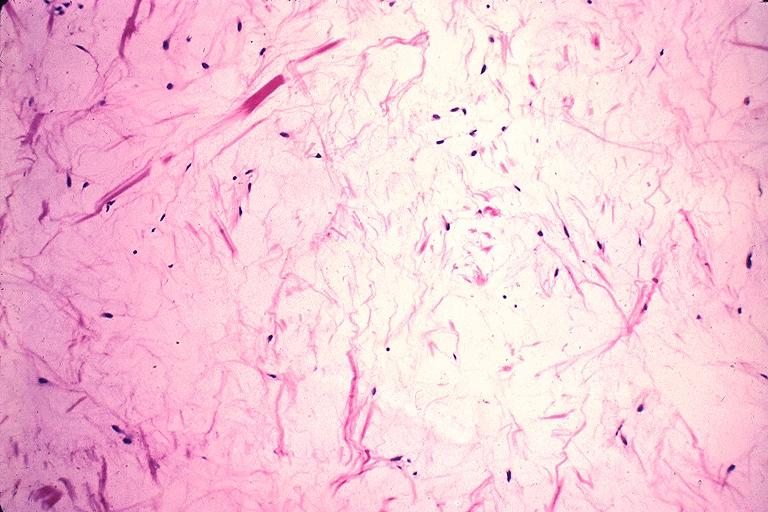does this image show odontogenic myxoma?
Answer the question using a single word or phrase. Yes 